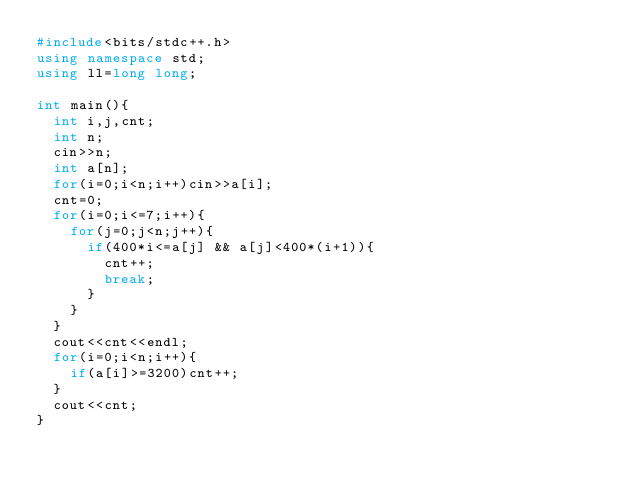Convert code to text. <code><loc_0><loc_0><loc_500><loc_500><_C++_>#include<bits/stdc++.h>
using namespace std;
using ll=long long;

int main(){
  int i,j,cnt;
  int n;
  cin>>n;
  int a[n];
  for(i=0;i<n;i++)cin>>a[i];
  cnt=0;
  for(i=0;i<=7;i++){
    for(j=0;j<n;j++){
      if(400*i<=a[j] && a[j]<400*(i+1)){
        cnt++;
        break;
      }
    }
  }
  cout<<cnt<<endl;
  for(i=0;i<n;i++){
    if(a[i]>=3200)cnt++;
  }
  cout<<cnt;
}</code> 